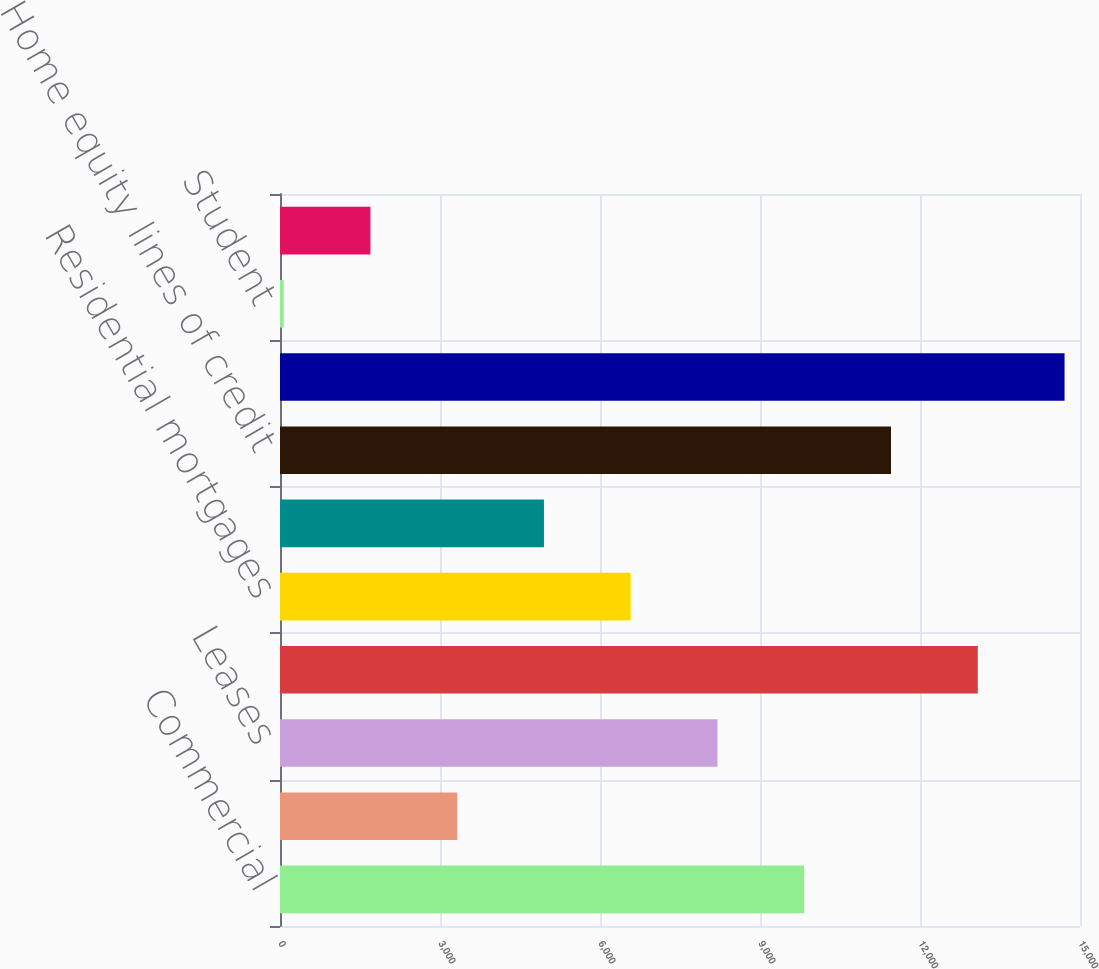Convert chart. <chart><loc_0><loc_0><loc_500><loc_500><bar_chart><fcel>Commercial<fcel>Commercial real estate<fcel>Leases<fcel>Total commercial<fcel>Residential mortgages<fcel>Home equity loans<fcel>Home equity lines of credit<fcel>Automobile<fcel>Student<fcel>Other retail<nl><fcel>9829.8<fcel>3322.6<fcel>8203<fcel>13083.4<fcel>6576.2<fcel>4949.4<fcel>11456.6<fcel>14710.2<fcel>69<fcel>1695.8<nl></chart> 